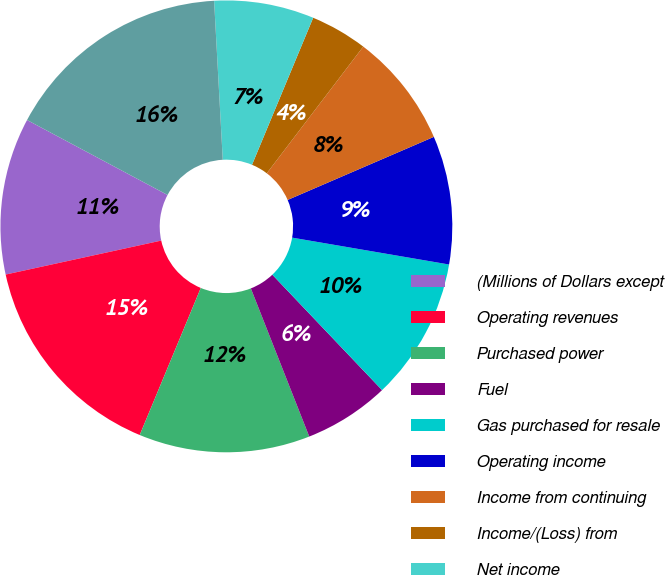Convert chart. <chart><loc_0><loc_0><loc_500><loc_500><pie_chart><fcel>(Millions of Dollars except<fcel>Operating revenues<fcel>Purchased power<fcel>Fuel<fcel>Gas purchased for resale<fcel>Operating income<fcel>Income from continuing<fcel>Income/(Loss) from<fcel>Net income<fcel>Total assets<nl><fcel>11.22%<fcel>15.31%<fcel>12.24%<fcel>6.12%<fcel>10.2%<fcel>9.18%<fcel>8.16%<fcel>4.08%<fcel>7.14%<fcel>16.33%<nl></chart> 